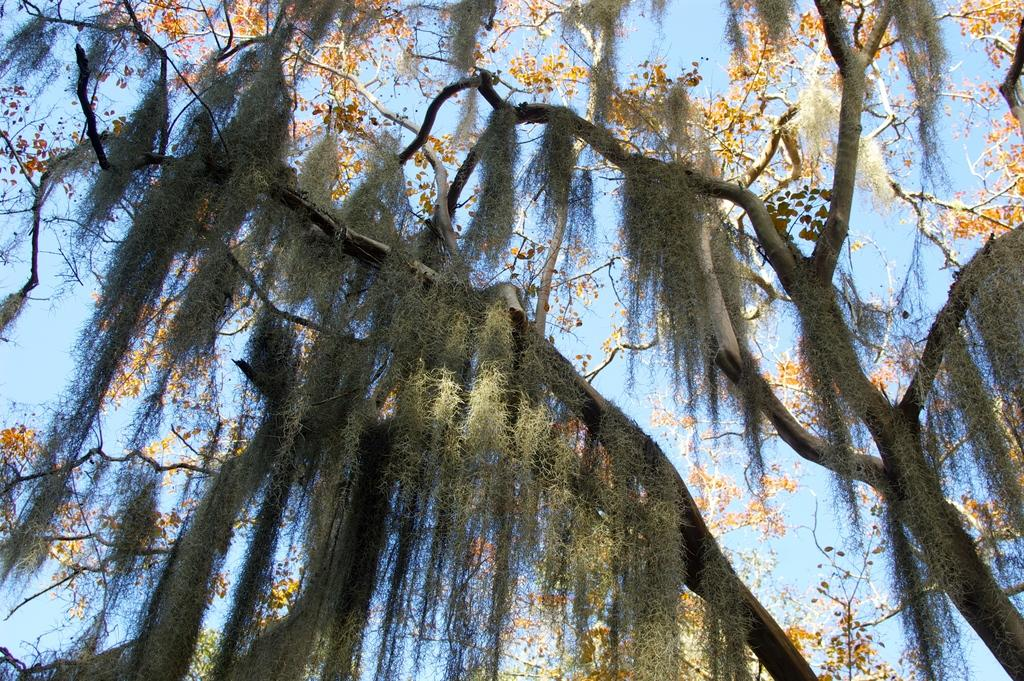What type of vegetation can be seen in the image? There are leaves and flowers of the trees in the image. What part of the natural environment is visible in the image? The sky is visible in the image. Can you describe the vegetation in more detail? The leaves and flowers are likely from trees, as they are mentioned as being part of the trees in the image. What advice does the tree give to the flowers in the image? There is no indication in the image that the tree is giving advice to the flowers, as plants do not communicate in this manner. 